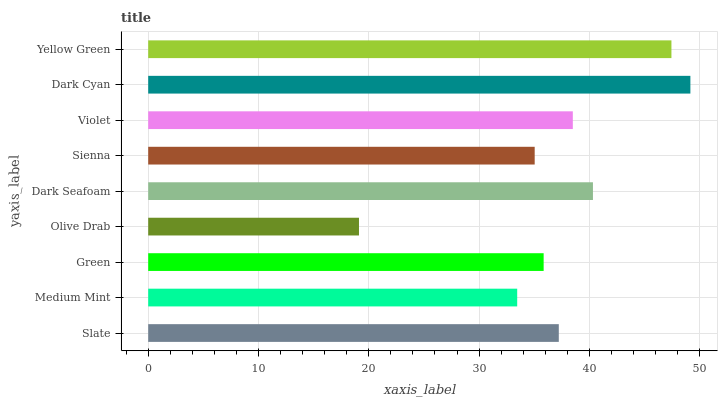Is Olive Drab the minimum?
Answer yes or no. Yes. Is Dark Cyan the maximum?
Answer yes or no. Yes. Is Medium Mint the minimum?
Answer yes or no. No. Is Medium Mint the maximum?
Answer yes or no. No. Is Slate greater than Medium Mint?
Answer yes or no. Yes. Is Medium Mint less than Slate?
Answer yes or no. Yes. Is Medium Mint greater than Slate?
Answer yes or no. No. Is Slate less than Medium Mint?
Answer yes or no. No. Is Slate the high median?
Answer yes or no. Yes. Is Slate the low median?
Answer yes or no. Yes. Is Dark Cyan the high median?
Answer yes or no. No. Is Dark Seafoam the low median?
Answer yes or no. No. 